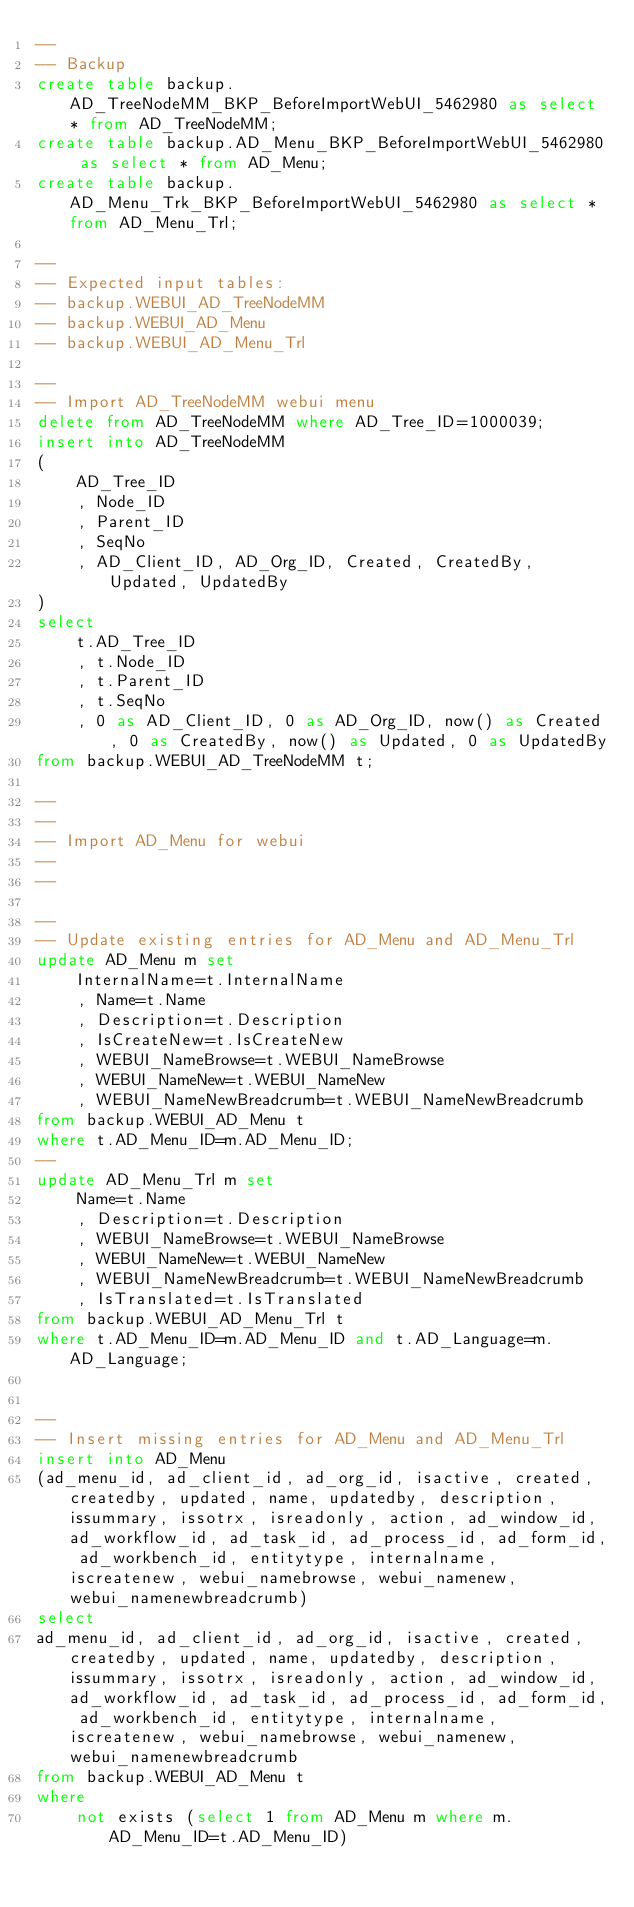Convert code to text. <code><loc_0><loc_0><loc_500><loc_500><_SQL_>--
-- Backup
create table backup.AD_TreeNodeMM_BKP_BeforeImportWebUI_5462980 as select * from AD_TreeNodeMM;
create table backup.AD_Menu_BKP_BeforeImportWebUI_5462980 as select * from AD_Menu;
create table backup.AD_Menu_Trk_BKP_BeforeImportWebUI_5462980 as select * from AD_Menu_Trl;

--
-- Expected input tables:
-- backup.WEBUI_AD_TreeNodeMM
-- backup.WEBUI_AD_Menu
-- backup.WEBUI_AD_Menu_Trl

--
-- Import AD_TreeNodeMM webui menu
delete from AD_TreeNodeMM where AD_Tree_ID=1000039;
insert into AD_TreeNodeMM
(
	AD_Tree_ID
	, Node_ID
	, Parent_ID
	, SeqNo
	, AD_Client_ID, AD_Org_ID, Created, CreatedBy, Updated, UpdatedBy
)
select
	t.AD_Tree_ID
	, t.Node_ID
	, t.Parent_ID
	, t.SeqNo
	, 0 as AD_Client_ID, 0 as AD_Org_ID, now() as Created, 0 as CreatedBy, now() as Updated, 0 as UpdatedBy
from backup.WEBUI_AD_TreeNodeMM t;

--
--
-- Import AD_Menu for webui
--
--

--
-- Update existing entries for AD_Menu and AD_Menu_Trl
update AD_Menu m set
	InternalName=t.InternalName
	, Name=t.Name
	, Description=t.Description
	, IsCreateNew=t.IsCreateNew
	, WEBUI_NameBrowse=t.WEBUI_NameBrowse
	, WEBUI_NameNew=t.WEBUI_NameNew
	, WEBUI_NameNewBreadcrumb=t.WEBUI_NameNewBreadcrumb
from backup.WEBUI_AD_Menu t
where t.AD_Menu_ID=m.AD_Menu_ID;
--
update AD_Menu_Trl m set
	Name=t.Name
	, Description=t.Description
	, WEBUI_NameBrowse=t.WEBUI_NameBrowse
	, WEBUI_NameNew=t.WEBUI_NameNew
	, WEBUI_NameNewBreadcrumb=t.WEBUI_NameNewBreadcrumb
	, IsTranslated=t.IsTranslated
from backup.WEBUI_AD_Menu_Trl t
where t.AD_Menu_ID=m.AD_Menu_ID and t.AD_Language=m.AD_Language;


--
-- Insert missing entries for AD_Menu and AD_Menu_Trl
insert into AD_Menu
(ad_menu_id, ad_client_id, ad_org_id, isactive, created, createdby, updated, name, updatedby, description, issummary, issotrx, isreadonly, action, ad_window_id, ad_workflow_id, ad_task_id, ad_process_id, ad_form_id, ad_workbench_id, entitytype, internalname, iscreatenew, webui_namebrowse, webui_namenew, webui_namenewbreadcrumb)
select
ad_menu_id, ad_client_id, ad_org_id, isactive, created, createdby, updated, name, updatedby, description, issummary, issotrx, isreadonly, action, ad_window_id, ad_workflow_id, ad_task_id, ad_process_id, ad_form_id, ad_workbench_id, entitytype, internalname, iscreatenew, webui_namebrowse, webui_namenew, webui_namenewbreadcrumb
from backup.WEBUI_AD_Menu t
where
	not exists (select 1 from AD_Menu m where m.AD_Menu_ID=t.AD_Menu_ID)</code> 